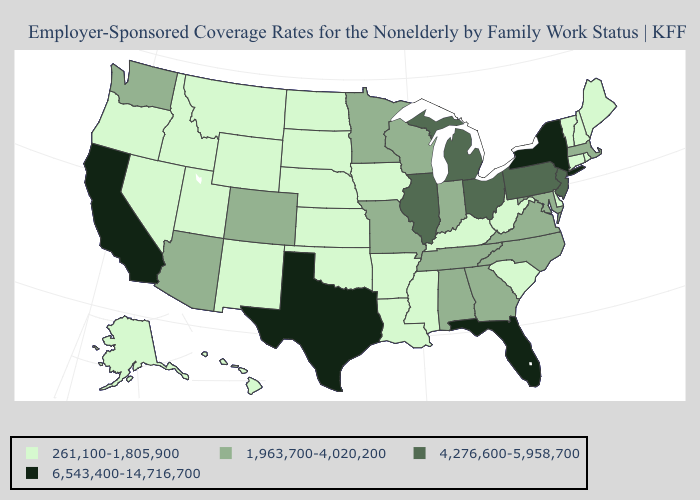Among the states that border New Jersey , which have the lowest value?
Keep it brief. Delaware. Name the states that have a value in the range 6,543,400-14,716,700?
Quick response, please. California, Florida, New York, Texas. What is the highest value in the USA?
Give a very brief answer. 6,543,400-14,716,700. Name the states that have a value in the range 6,543,400-14,716,700?
Answer briefly. California, Florida, New York, Texas. Does Oklahoma have the lowest value in the USA?
Concise answer only. Yes. What is the value of Connecticut?
Be succinct. 261,100-1,805,900. What is the value of Nevada?
Be succinct. 261,100-1,805,900. Which states have the lowest value in the Northeast?
Be succinct. Connecticut, Maine, New Hampshire, Rhode Island, Vermont. Does Rhode Island have a lower value than Michigan?
Write a very short answer. Yes. What is the value of North Dakota?
Concise answer only. 261,100-1,805,900. Does California have a higher value than Maine?
Answer briefly. Yes. Name the states that have a value in the range 4,276,600-5,958,700?
Be succinct. Illinois, Michigan, New Jersey, Ohio, Pennsylvania. What is the value of New Jersey?
Short answer required. 4,276,600-5,958,700. Does Ohio have the lowest value in the MidWest?
Answer briefly. No. 